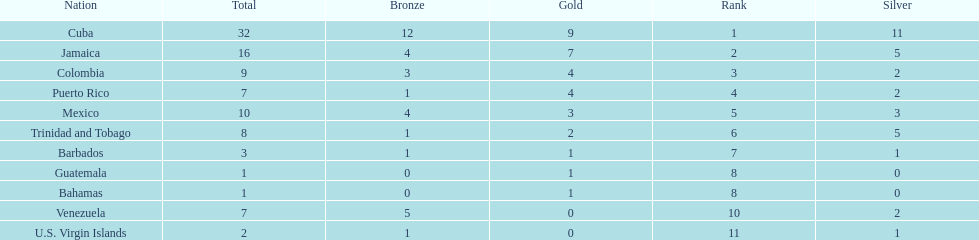Nations that had 10 or more medals each Cuba, Jamaica, Mexico. 